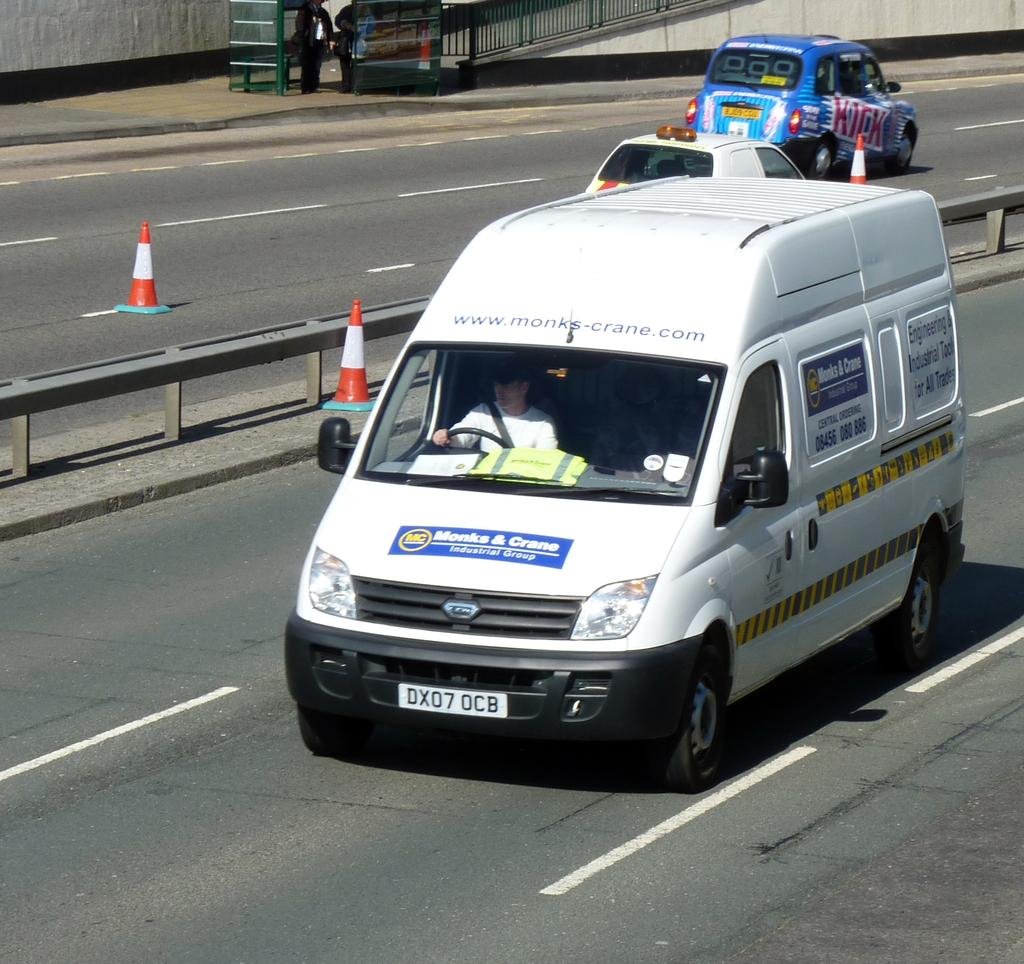<image>
Provide a brief description of the given image. a Monks and Crane van that is on the street 